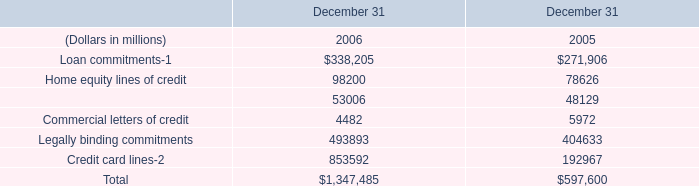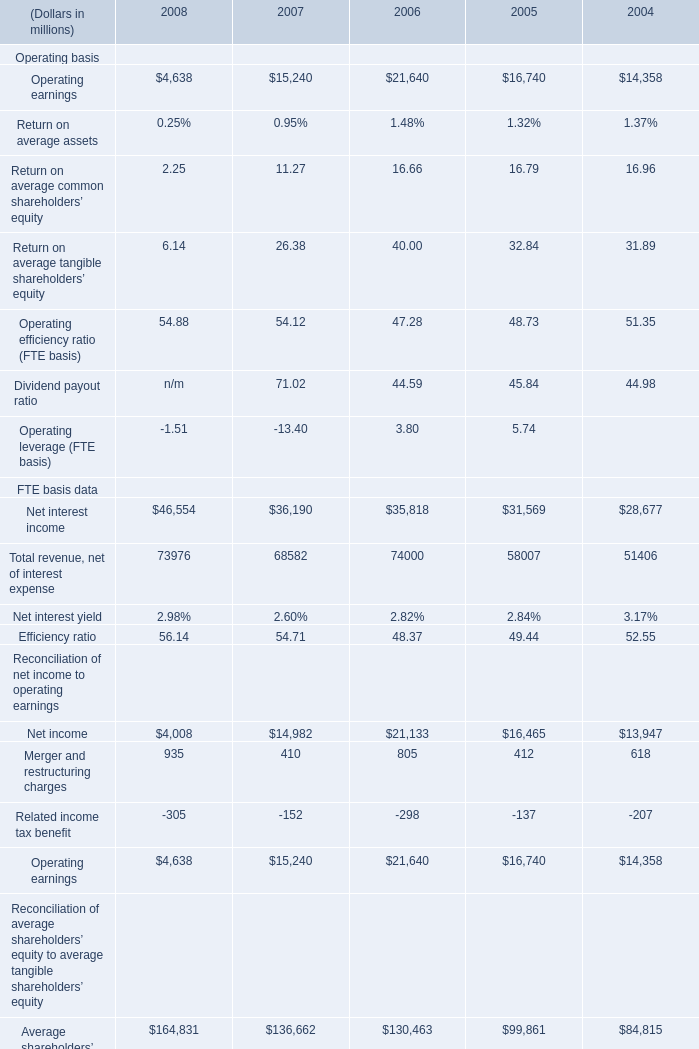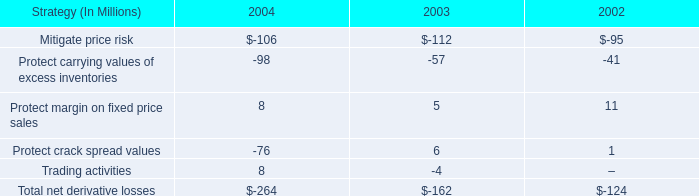What's the average of Net interest income FTE basis data of 2006, and Loan commitments of December 31 2005 ? 
Computations: ((35818.0 + 271906.0) / 2)
Answer: 153862.0. 